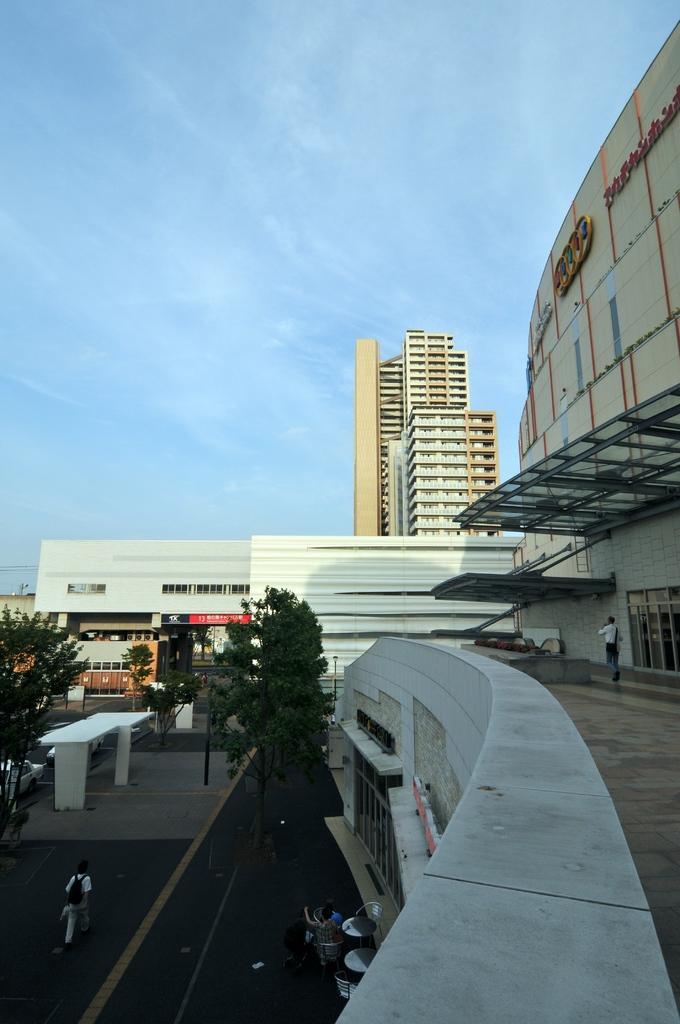Describe this image in one or two sentences. In this image I can see few people walking on the road, trees in green color, buildings in white and cream color and the sky is in blue color. 